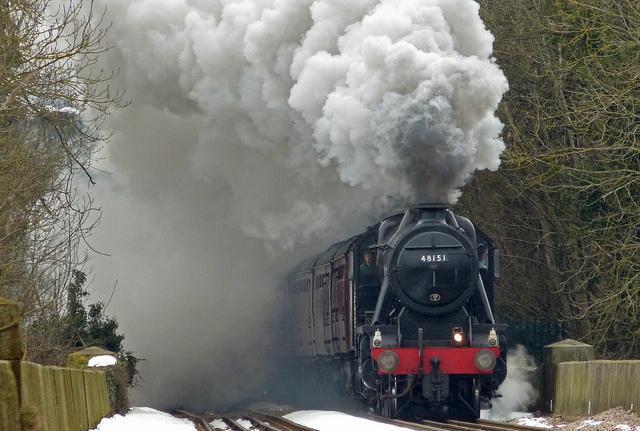How many trains can be seen?
Give a very brief answer. 1. 